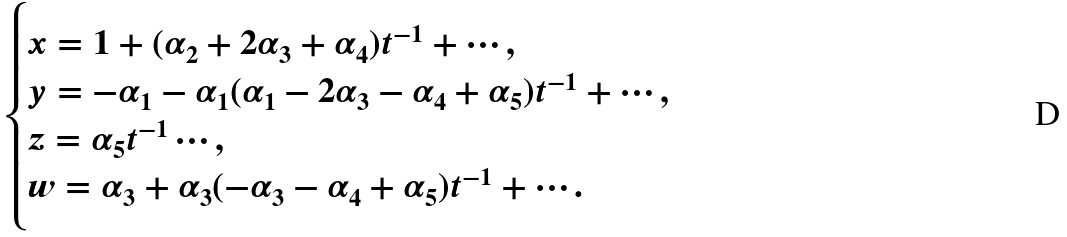Convert formula to latex. <formula><loc_0><loc_0><loc_500><loc_500>\begin{cases} x = 1 + ( \alpha _ { 2 } + 2 \alpha _ { 3 } + \alpha _ { 4 } ) t ^ { - 1 } + \cdots , \\ y = - \alpha _ { 1 } - \alpha _ { 1 } ( \alpha _ { 1 } - 2 \alpha _ { 3 } - \alpha _ { 4 } + \alpha _ { 5 } ) t ^ { - 1 } + \cdots , \\ z = \alpha _ { 5 } t ^ { - 1 } \cdots , \\ w = \alpha _ { 3 } + \alpha _ { 3 } ( - \alpha _ { 3 } - \alpha _ { 4 } + \alpha _ { 5 } ) t ^ { - 1 } + \cdots . \end{cases}</formula> 